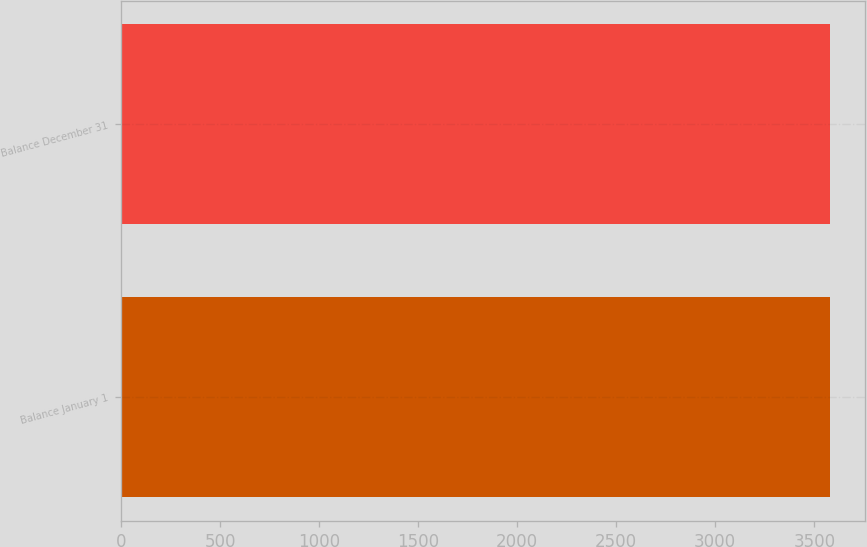Convert chart. <chart><loc_0><loc_0><loc_500><loc_500><bar_chart><fcel>Balance January 1<fcel>Balance December 31<nl><fcel>3577<fcel>3577.1<nl></chart> 